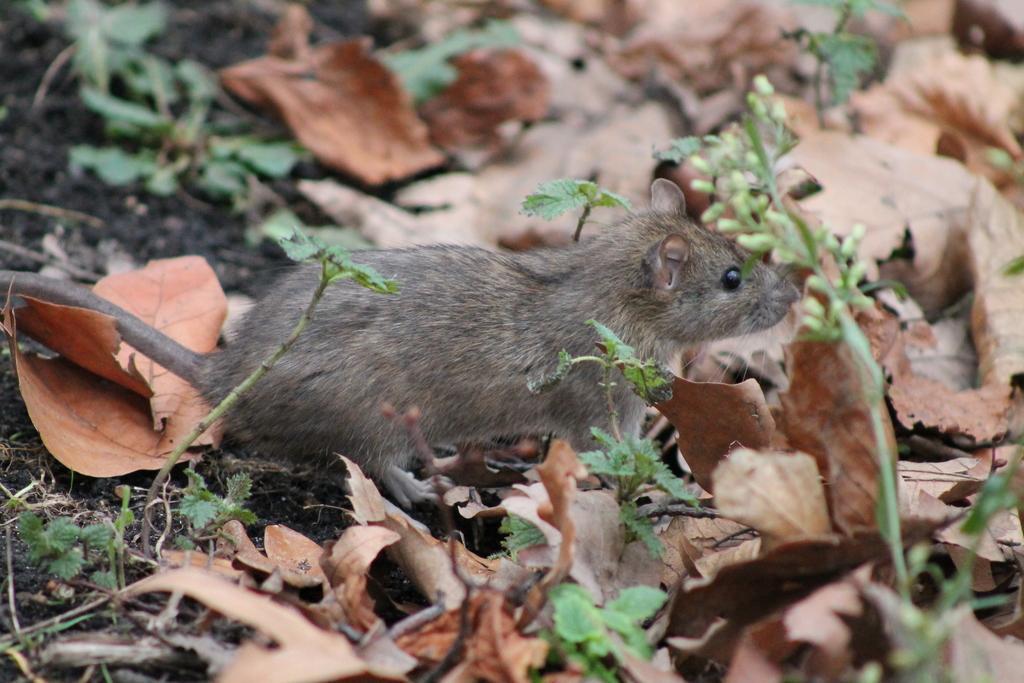Can you describe this image briefly? In this picture I can see a mouse and grass. I can also see some leaves on the ground. 